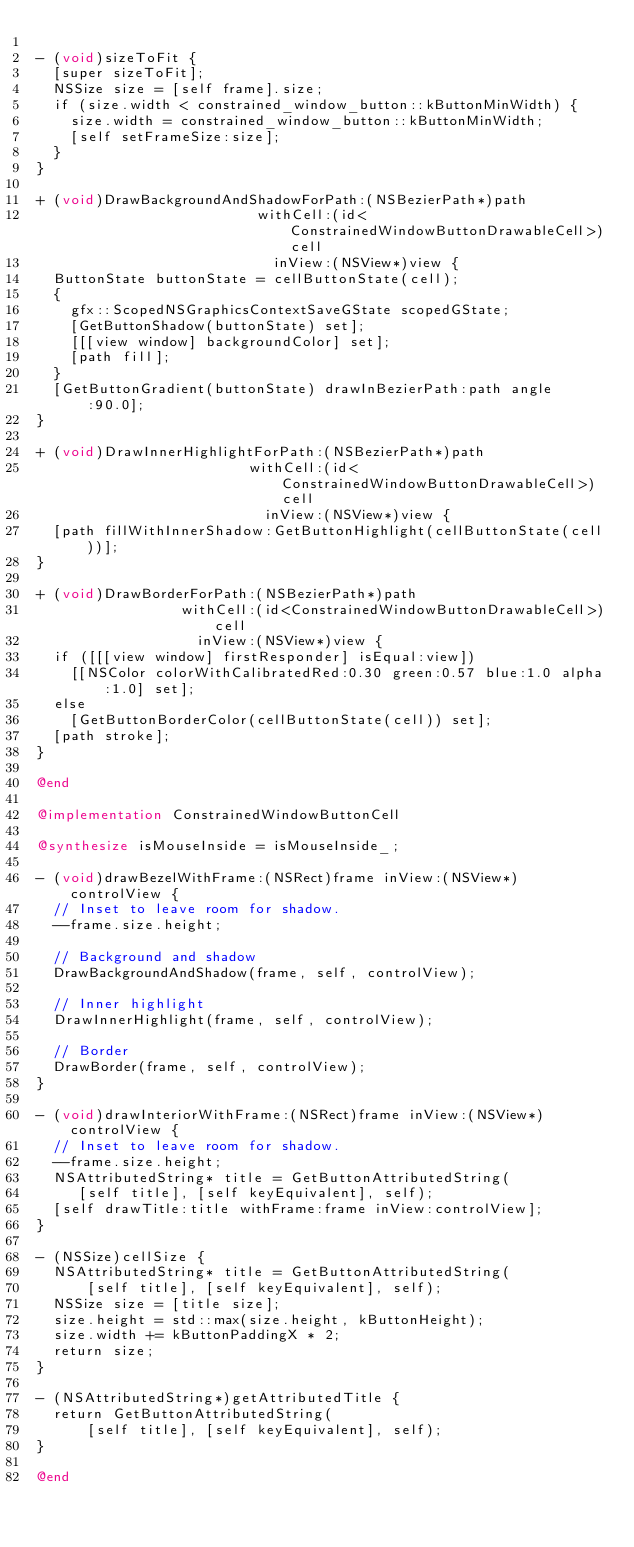<code> <loc_0><loc_0><loc_500><loc_500><_ObjectiveC_>
- (void)sizeToFit {
  [super sizeToFit];
  NSSize size = [self frame].size;
  if (size.width < constrained_window_button::kButtonMinWidth) {
    size.width = constrained_window_button::kButtonMinWidth;
    [self setFrameSize:size];
  }
}

+ (void)DrawBackgroundAndShadowForPath:(NSBezierPath*)path
                          withCell:(id<ConstrainedWindowButtonDrawableCell>)cell
                            inView:(NSView*)view {
  ButtonState buttonState = cellButtonState(cell);
  {
    gfx::ScopedNSGraphicsContextSaveGState scopedGState;
    [GetButtonShadow(buttonState) set];
    [[[view window] backgroundColor] set];
    [path fill];
  }
  [GetButtonGradient(buttonState) drawInBezierPath:path angle:90.0];
}

+ (void)DrawInnerHighlightForPath:(NSBezierPath*)path
                         withCell:(id<ConstrainedWindowButtonDrawableCell>)cell
                           inView:(NSView*)view {
  [path fillWithInnerShadow:GetButtonHighlight(cellButtonState(cell))];
}

+ (void)DrawBorderForPath:(NSBezierPath*)path
                 withCell:(id<ConstrainedWindowButtonDrawableCell>)cell
                   inView:(NSView*)view {
  if ([[[view window] firstResponder] isEqual:view])
    [[NSColor colorWithCalibratedRed:0.30 green:0.57 blue:1.0 alpha:1.0] set];
  else
    [GetButtonBorderColor(cellButtonState(cell)) set];
  [path stroke];
}

@end

@implementation ConstrainedWindowButtonCell

@synthesize isMouseInside = isMouseInside_;

- (void)drawBezelWithFrame:(NSRect)frame inView:(NSView*)controlView {
  // Inset to leave room for shadow.
  --frame.size.height;

  // Background and shadow
  DrawBackgroundAndShadow(frame, self, controlView);

  // Inner highlight
  DrawInnerHighlight(frame, self, controlView);

  // Border
  DrawBorder(frame, self, controlView);
}

- (void)drawInteriorWithFrame:(NSRect)frame inView:(NSView*)controlView {
  // Inset to leave room for shadow.
  --frame.size.height;
  NSAttributedString* title = GetButtonAttributedString(
     [self title], [self keyEquivalent], self);
  [self drawTitle:title withFrame:frame inView:controlView];
}

- (NSSize)cellSize {
  NSAttributedString* title = GetButtonAttributedString(
      [self title], [self keyEquivalent], self);
  NSSize size = [title size];
  size.height = std::max(size.height, kButtonHeight);
  size.width += kButtonPaddingX * 2;
  return size;
}

- (NSAttributedString*)getAttributedTitle {
  return GetButtonAttributedString(
      [self title], [self keyEquivalent], self);
}

@end
</code> 